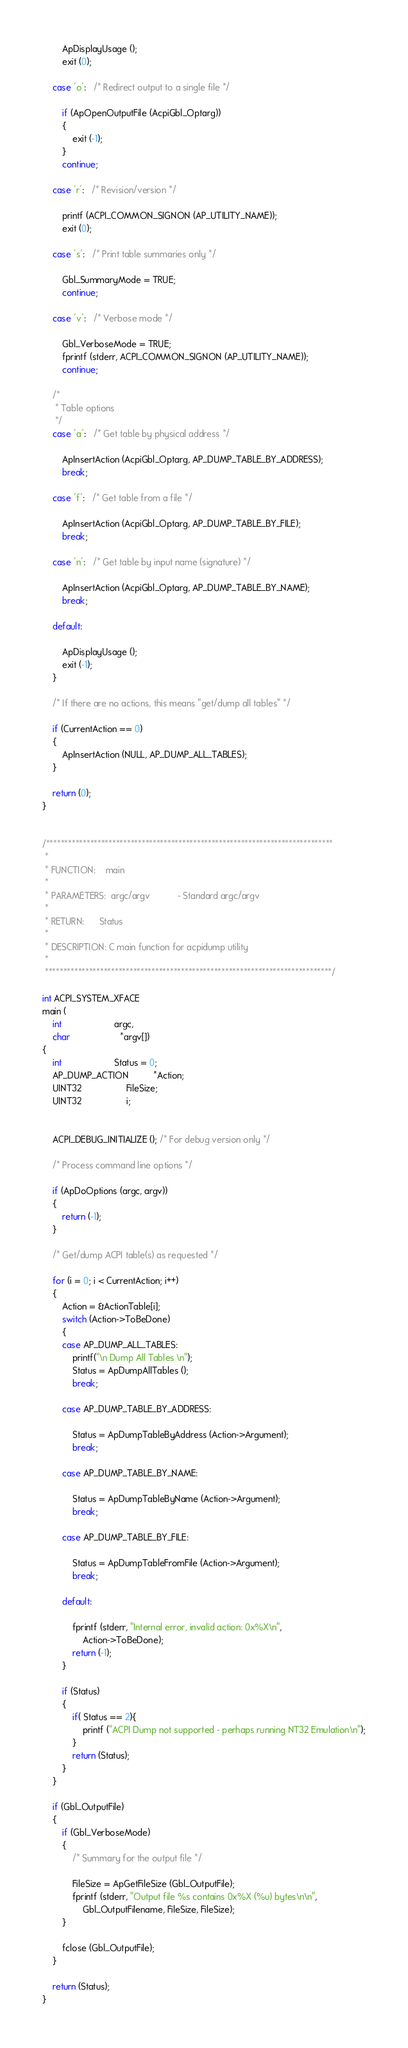Convert code to text. <code><loc_0><loc_0><loc_500><loc_500><_C_>        ApDisplayUsage ();
        exit (0);

    case 'o':   /* Redirect output to a single file */

        if (ApOpenOutputFile (AcpiGbl_Optarg))
        {
            exit (-1);
        }
        continue;

    case 'r':   /* Revision/version */

        printf (ACPI_COMMON_SIGNON (AP_UTILITY_NAME));
        exit (0);

    case 's':   /* Print table summaries only */

        Gbl_SummaryMode = TRUE;
        continue;

    case 'v':   /* Verbose mode */

        Gbl_VerboseMode = TRUE;
        fprintf (stderr, ACPI_COMMON_SIGNON (AP_UTILITY_NAME));
        continue;

    /*
     * Table options
     */
    case 'a':   /* Get table by physical address */

        ApInsertAction (AcpiGbl_Optarg, AP_DUMP_TABLE_BY_ADDRESS);
        break;

    case 'f':   /* Get table from a file */

        ApInsertAction (AcpiGbl_Optarg, AP_DUMP_TABLE_BY_FILE);
        break;

    case 'n':   /* Get table by input name (signature) */

        ApInsertAction (AcpiGbl_Optarg, AP_DUMP_TABLE_BY_NAME);
        break;

    default:

        ApDisplayUsage ();
        exit (-1);
    }

    /* If there are no actions, this means "get/dump all tables" */

    if (CurrentAction == 0)
    {
        ApInsertAction (NULL, AP_DUMP_ALL_TABLES);
    }

    return (0);
}


/******************************************************************************
 *
 * FUNCTION:    main
 *
 * PARAMETERS:  argc/argv           - Standard argc/argv
 *
 * RETURN:      Status
 *
 * DESCRIPTION: C main function for acpidump utility
 *
 ******************************************************************************/

int ACPI_SYSTEM_XFACE
main (
    int                     argc,
    char                    *argv[])
{
    int                     Status = 0;
    AP_DUMP_ACTION          *Action;
    UINT32                  FileSize;
    UINT32                  i;


    ACPI_DEBUG_INITIALIZE (); /* For debug version only */

    /* Process command line options */

    if (ApDoOptions (argc, argv))
    {
        return (-1);
    }

    /* Get/dump ACPI table(s) as requested */

    for (i = 0; i < CurrentAction; i++)
    {
        Action = &ActionTable[i];
        switch (Action->ToBeDone)
        {
        case AP_DUMP_ALL_TABLES:
			printf("\n Dump All Tables \n");
            Status = ApDumpAllTables ();
			break;

        case AP_DUMP_TABLE_BY_ADDRESS:

            Status = ApDumpTableByAddress (Action->Argument);
            break;

        case AP_DUMP_TABLE_BY_NAME:

            Status = ApDumpTableByName (Action->Argument);
            break;

        case AP_DUMP_TABLE_BY_FILE:

            Status = ApDumpTableFromFile (Action->Argument);
            break;

        default:

            fprintf (stderr, "Internal error, invalid action: 0x%X\n",
                Action->ToBeDone);
            return (-1);
        }

        if (Status)
        {
 		    if( Status == 2){
				printf ("ACPI Dump not supported - perhaps running NT32 Emulation\n");
			}
            return (Status);
        }
    }

    if (Gbl_OutputFile)
    {
        if (Gbl_VerboseMode)
        {
            /* Summary for the output file */

            FileSize = ApGetFileSize (Gbl_OutputFile);
            fprintf (stderr, "Output file %s contains 0x%X (%u) bytes\n\n",
                Gbl_OutputFilename, FileSize, FileSize);
        }

        fclose (Gbl_OutputFile);
    }

    return (Status);
}
</code> 